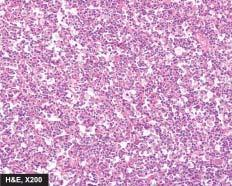does the sequence on left show uniform cells having high mitotic rate?
Answer the question using a single word or phrase. No 